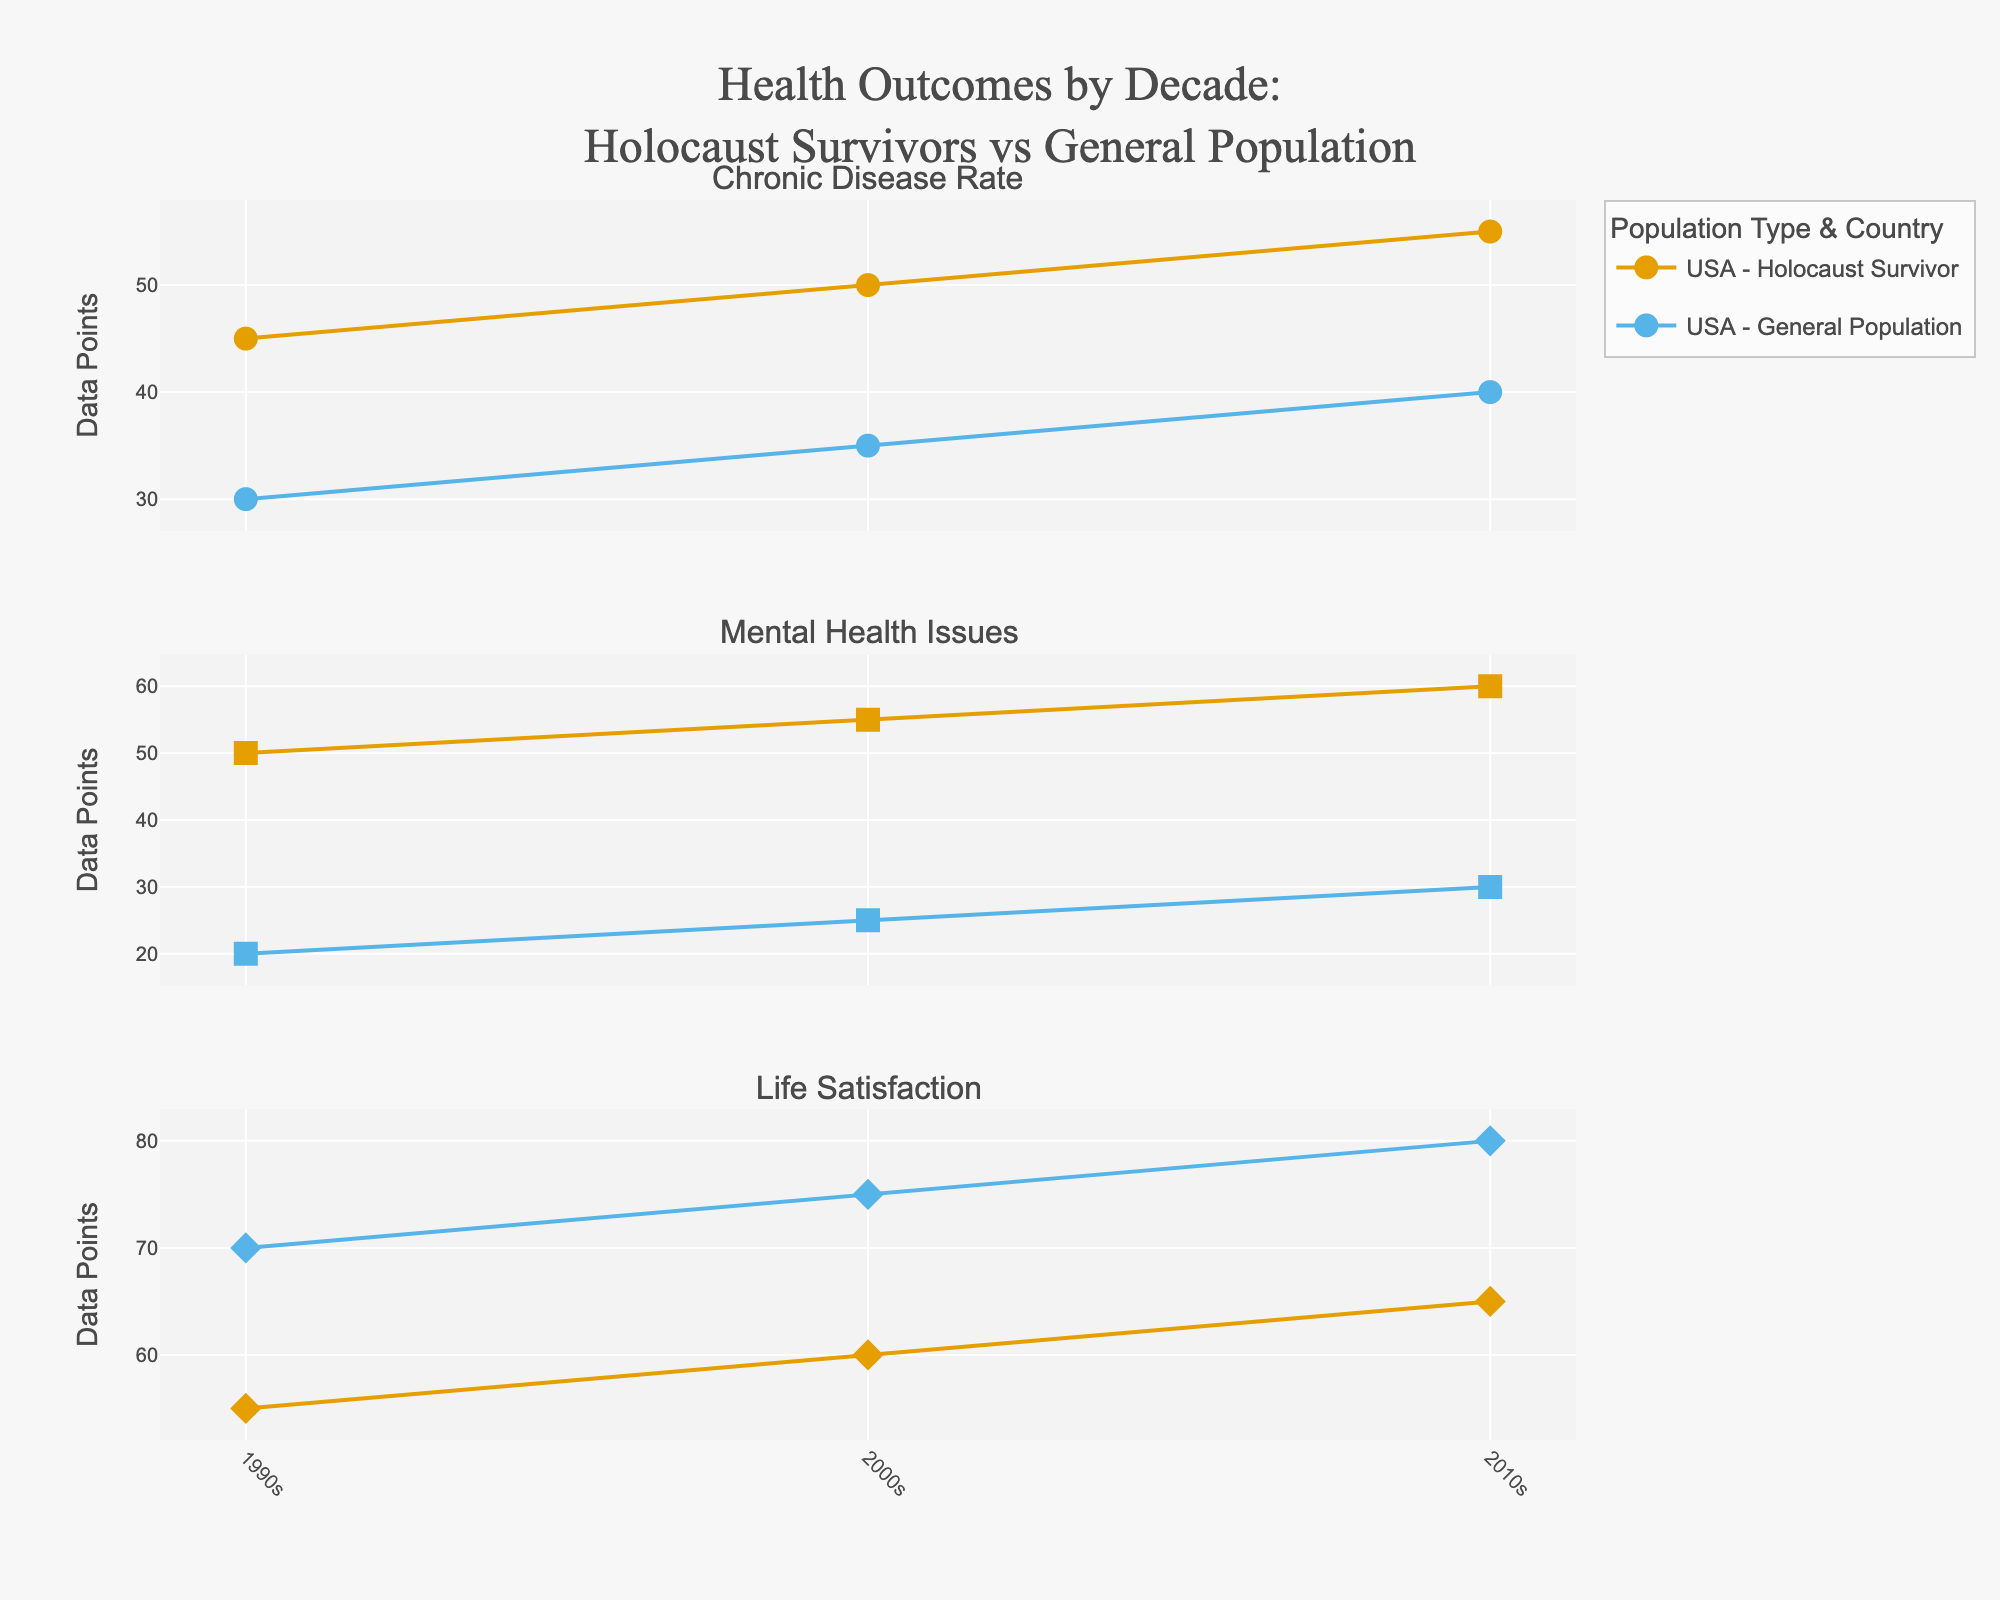What is the title of the plot? The title is located at the top center of the plot, in larger font size compared to other texts. It reads "Health Outcomes by Decade: Holocaust Survivors vs General Population".
Answer: Health Outcomes by Decade: Holocaust Survivors vs General Population How many subplots are there? The subplot titles indicate the number of subplots. Each unique health outcome (Chronic Disease Rate, Mental Health Issues, Life Satisfaction) leads to a separate subplot.
Answer: 3 What symbol is used to represent the USA? The legend or marker shapes can reveal this information. The USA is represented by circles.
Answer: Circles Which population group in the USA has a higher Chronic Disease Rate in the 2000s? By examining the markers in the subplot for Chronic Disease Rate, the data points for Holocaust Survivors are higher compared to the General Population in the 2000s.
Answer: Holocaust Survivors What is the change in Chronic Disease Rate for Holocaust Survivors in the USA from the 1990s to the 2010s? The Chronic Disease Rate for Holocaust Survivors in the 1990s is 45, in the 2000s is 50, and in the 2010s is 55. The change from 1990s to 2010s is 55 - 45.
Answer: 10 Which country shows the highest Life Satisfaction for Holocaust Survivors in the 2010s? By checking the markers in the subplot for Life Satisfaction in the 2010s, Poland shows the highest value among the countries for Holocaust Survivors.
Answer: Poland How does the Mental Health Issues rate in Germany compare between Holocaust Survivors and the General Population in the 1990s? For the subplot on Mental Health Issues for the 1990s in Germany, Holocaust Survivors show a much higher rate (50) compared to the General Population (20).
Answer: Holocaust Survivors have a higher rate What is the overall trend for Life Satisfaction in Poland for both population groups from the 1990s to 2010s? Plotting the data points for Life Satisfaction over the decades for both Holocaust Survivors and General Population in Poland shows an upward trend.
Answer: Upward trend Which health outcome shows a consistently increasing problem for Holocaust Survivors across all decades in the USA? By viewing the subplots of each health outcome, the Chronic Disease Rate for Holocaust Survivors in the USA shows a consistent increase across the 1990s, 2000s, and 2010s.
Answer: Chronic Disease Rate 